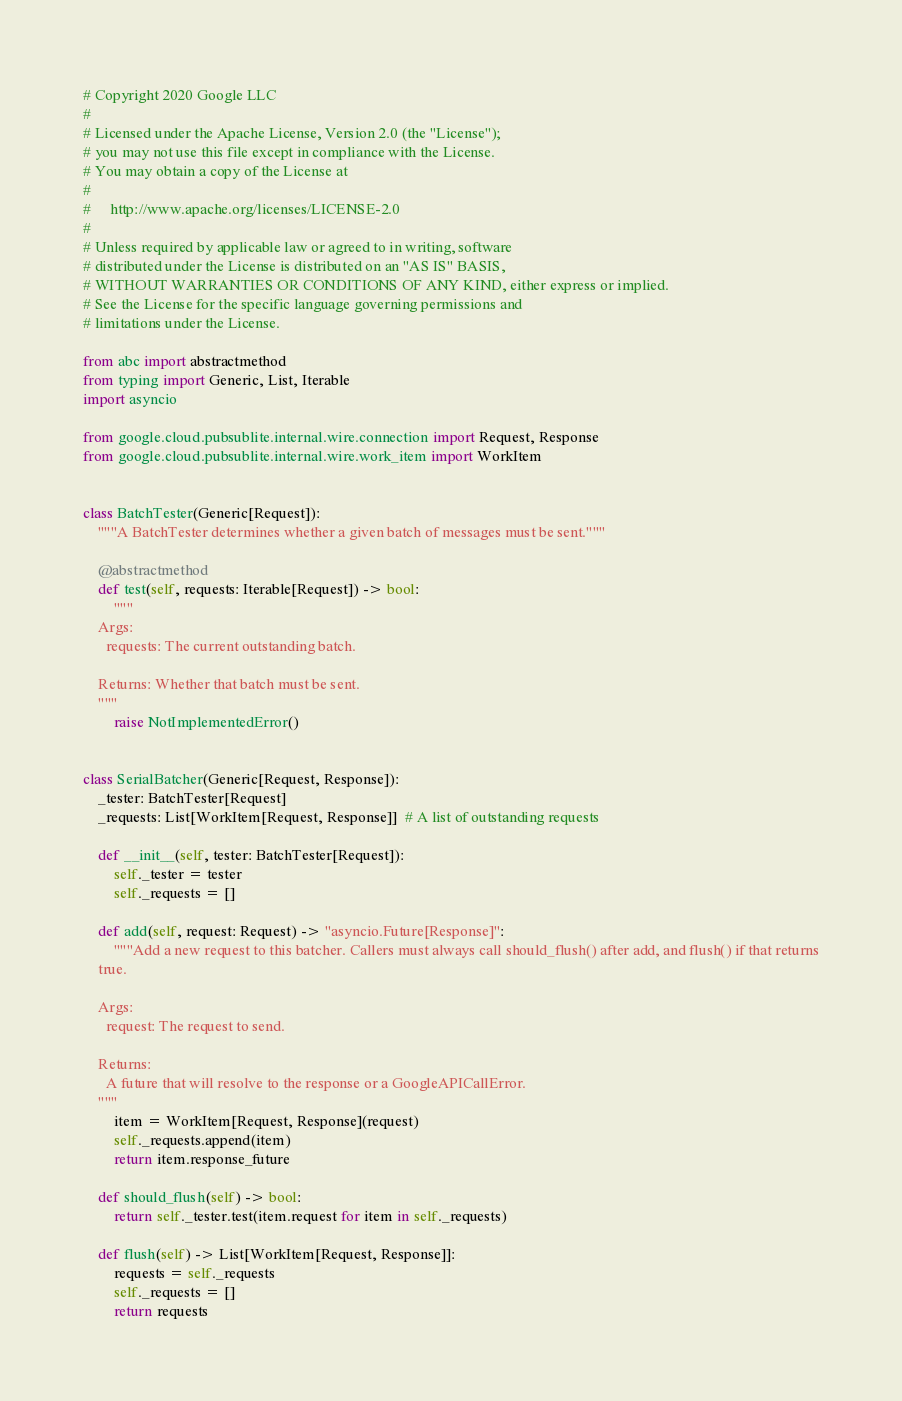Convert code to text. <code><loc_0><loc_0><loc_500><loc_500><_Python_># Copyright 2020 Google LLC
#
# Licensed under the Apache License, Version 2.0 (the "License");
# you may not use this file except in compliance with the License.
# You may obtain a copy of the License at
#
#     http://www.apache.org/licenses/LICENSE-2.0
#
# Unless required by applicable law or agreed to in writing, software
# distributed under the License is distributed on an "AS IS" BASIS,
# WITHOUT WARRANTIES OR CONDITIONS OF ANY KIND, either express or implied.
# See the License for the specific language governing permissions and
# limitations under the License.

from abc import abstractmethod
from typing import Generic, List, Iterable
import asyncio

from google.cloud.pubsublite.internal.wire.connection import Request, Response
from google.cloud.pubsublite.internal.wire.work_item import WorkItem


class BatchTester(Generic[Request]):
    """A BatchTester determines whether a given batch of messages must be sent."""

    @abstractmethod
    def test(self, requests: Iterable[Request]) -> bool:
        """
    Args:
      requests: The current outstanding batch.

    Returns: Whether that batch must be sent.
    """
        raise NotImplementedError()


class SerialBatcher(Generic[Request, Response]):
    _tester: BatchTester[Request]
    _requests: List[WorkItem[Request, Response]]  # A list of outstanding requests

    def __init__(self, tester: BatchTester[Request]):
        self._tester = tester
        self._requests = []

    def add(self, request: Request) -> "asyncio.Future[Response]":
        """Add a new request to this batcher. Callers must always call should_flush() after add, and flush() if that returns
    true.

    Args:
      request: The request to send.

    Returns:
      A future that will resolve to the response or a GoogleAPICallError.
    """
        item = WorkItem[Request, Response](request)
        self._requests.append(item)
        return item.response_future

    def should_flush(self) -> bool:
        return self._tester.test(item.request for item in self._requests)

    def flush(self) -> List[WorkItem[Request, Response]]:
        requests = self._requests
        self._requests = []
        return requests
</code> 